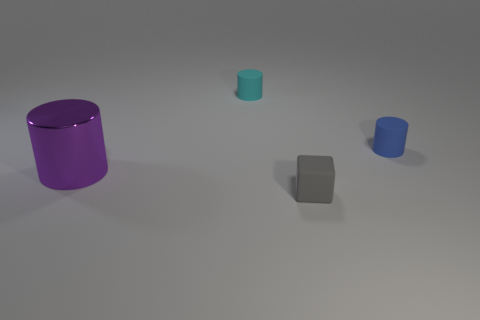Subtract all blue rubber cylinders. How many cylinders are left? 2 Add 1 big blue matte balls. How many objects exist? 5 Subtract all purple cylinders. How many cylinders are left? 2 Add 4 small gray matte objects. How many small gray matte objects exist? 5 Subtract 0 yellow balls. How many objects are left? 4 Subtract all cylinders. How many objects are left? 1 Subtract all green cubes. Subtract all brown spheres. How many cubes are left? 1 Subtract all brown blocks. How many yellow cylinders are left? 0 Subtract all small blue rubber cylinders. Subtract all large things. How many objects are left? 2 Add 4 small gray rubber cubes. How many small gray rubber cubes are left? 5 